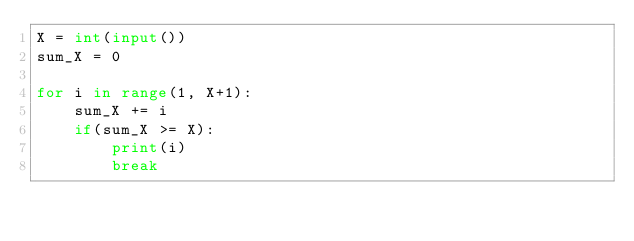Convert code to text. <code><loc_0><loc_0><loc_500><loc_500><_Python_>X = int(input())
sum_X = 0

for i in range(1, X+1):
    sum_X += i 
    if(sum_X >= X):
        print(i)
        break</code> 